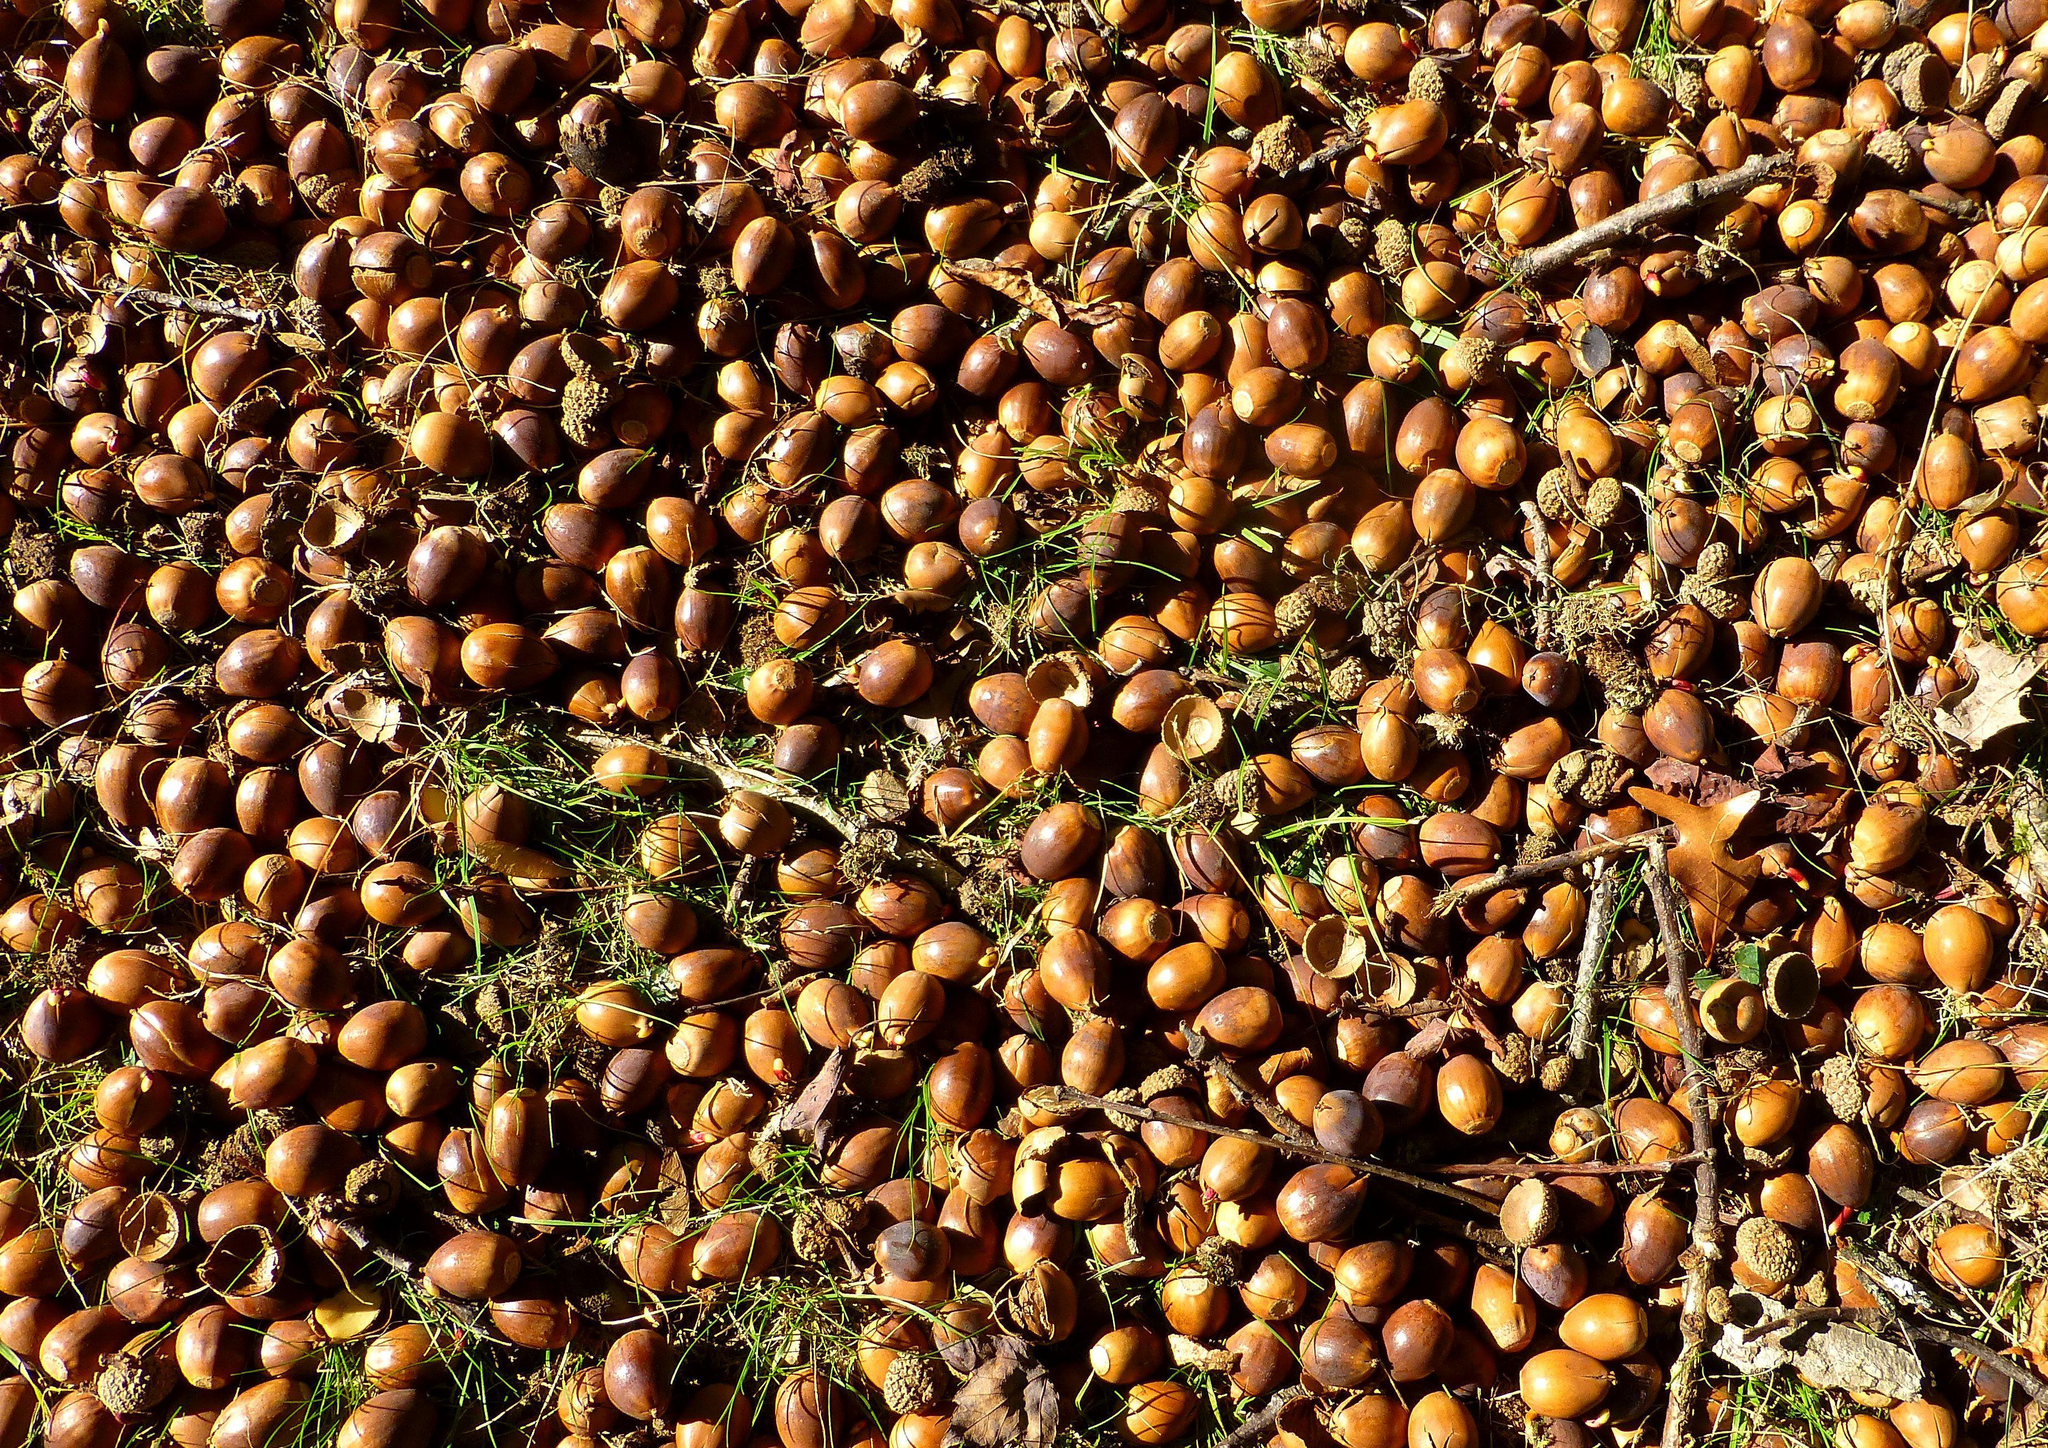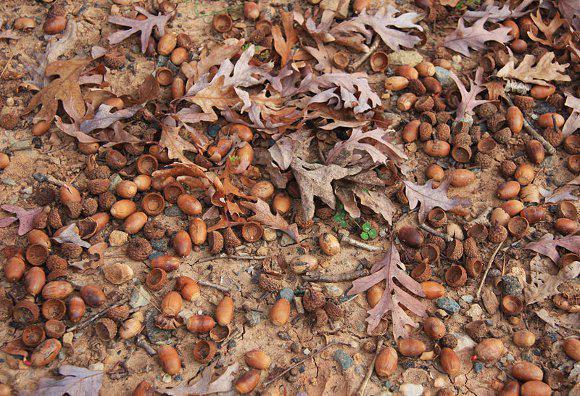The first image is the image on the left, the second image is the image on the right. For the images displayed, is the sentence "One image includes at least six recognizable autumn oak leaves amid a pile of fallen brown acorns and their separated caps." factually correct? Answer yes or no. Yes. The first image is the image on the left, the second image is the image on the right. Considering the images on both sides, is "In the image to the right, there is no green grass; there is merely one spot which contains a green plant at all." valid? Answer yes or no. Yes. 